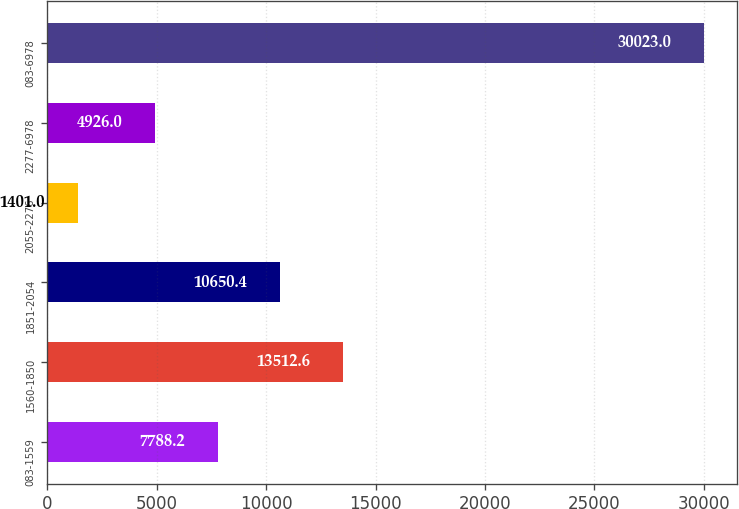<chart> <loc_0><loc_0><loc_500><loc_500><bar_chart><fcel>083-1559<fcel>1560-1850<fcel>1851-2054<fcel>2055-2276<fcel>2277-6978<fcel>083-6978<nl><fcel>7788.2<fcel>13512.6<fcel>10650.4<fcel>1401<fcel>4926<fcel>30023<nl></chart> 